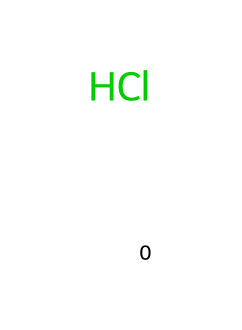What is the name of this chemical? The chemical structure provided corresponds to hydrochloric acid, as indicated by its SMILES notation. Hydrochloric acid consists of hydrogen and chlorine, which together make up HCl.
Answer: hydrochloric acid How many atoms are present in this molecule? The SMILES notation [H]Cl represents two distinct atoms: one hydrogen (H) and one chlorine (Cl), totaling two atoms in the structure.
Answer: two What type of bond exists between the hydrogen and chlorine? In the molecule represented, the bond between hydrogen and chlorine is a covalent bond. This is demonstrated by the pairing of the two different atoms, which share electrons to form a stable bond.
Answer: covalent bond Is this chemical considered a strong acid? Hydrochloric acid is classified as a strong acid due to its complete dissociation in water, leading to a high concentration of hydrogen ions (H+). This characteristic is derived from its behavior in aqueous solutions rather than just its molecular structure.
Answer: yes What is the primary use of hydrochloric acid in PCB etching? In PCB etching, hydrochloric acid is employed primarily to remove unwanted copper from the surface of the circuit board. This allows for the desired circuit pattern to remain, enhancing the functionality of the board.
Answer: removes copper Does this acid have a pungent odor? Hydrochloric acid typically has a strong and pungent odor, which is characteristic of many strong acids, and can be identified based on its chemical properties and typical handling experiences in laboratories and industries.
Answer: yes 